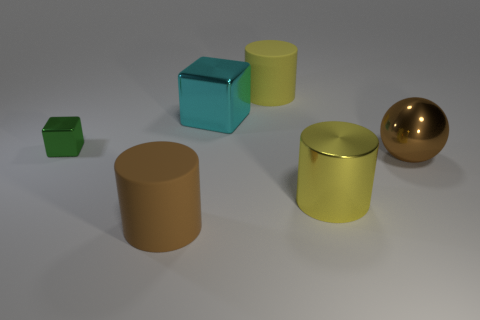How many big matte objects are behind the brown object behind the brown cylinder? Behind the brown cylinder, there appears to be only one large matte object, which is a green cube. 